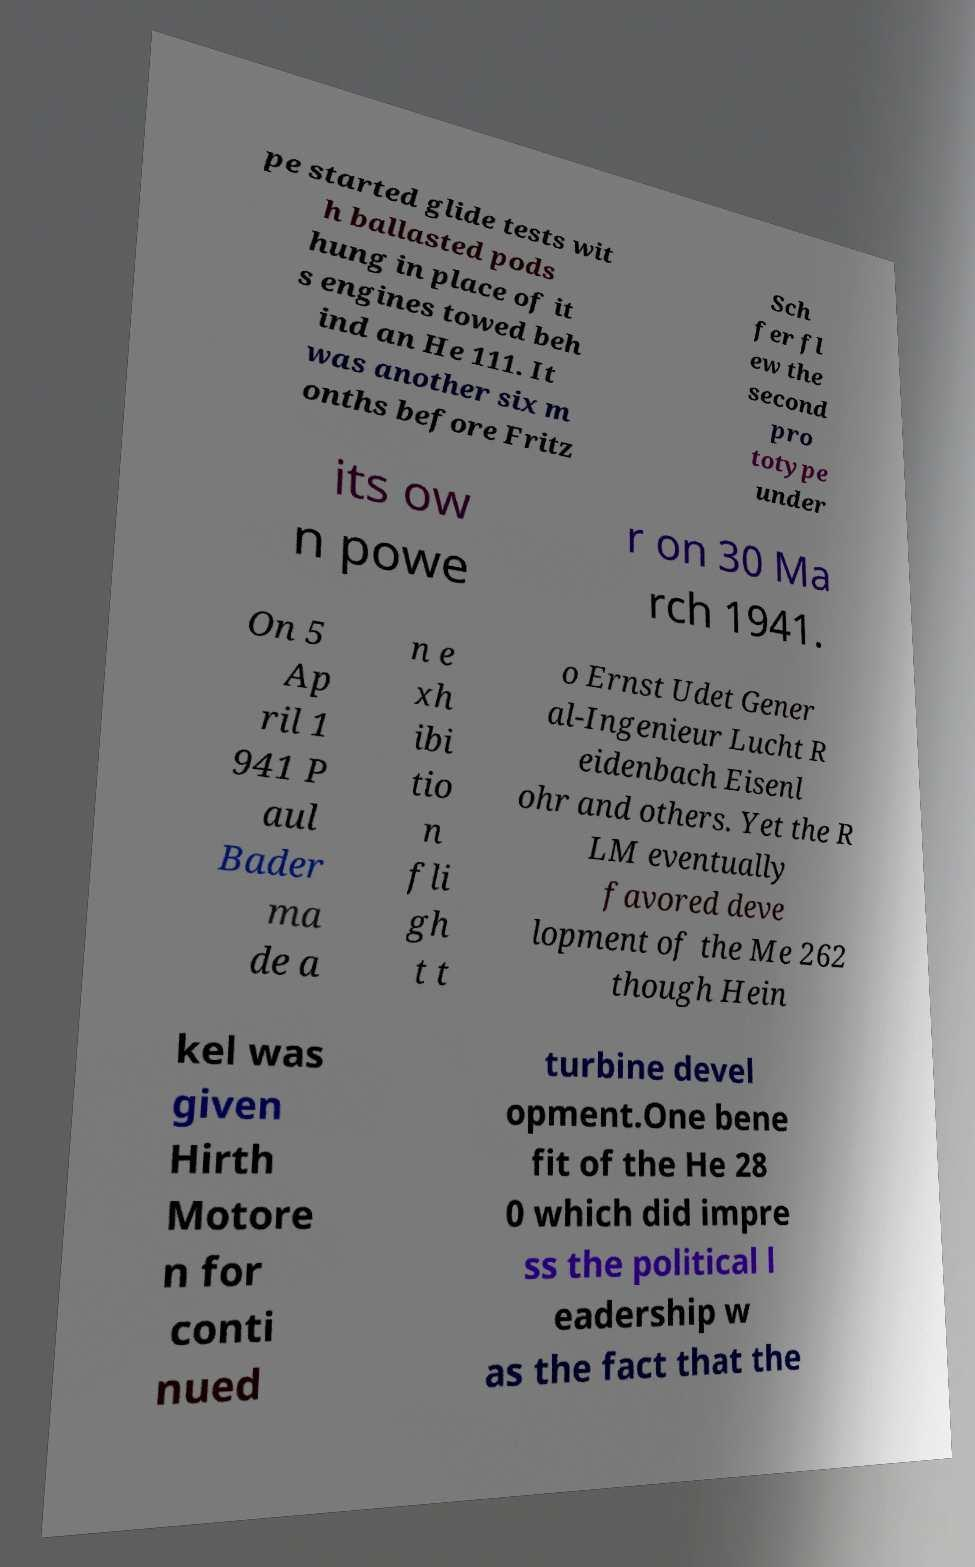Please read and relay the text visible in this image. What does it say? pe started glide tests wit h ballasted pods hung in place of it s engines towed beh ind an He 111. It was another six m onths before Fritz Sch fer fl ew the second pro totype under its ow n powe r on 30 Ma rch 1941. On 5 Ap ril 1 941 P aul Bader ma de a n e xh ibi tio n fli gh t t o Ernst Udet Gener al-Ingenieur Lucht R eidenbach Eisenl ohr and others. Yet the R LM eventually favored deve lopment of the Me 262 though Hein kel was given Hirth Motore n for conti nued turbine devel opment.One bene fit of the He 28 0 which did impre ss the political l eadership w as the fact that the 